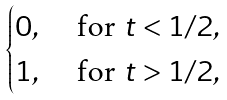<formula> <loc_0><loc_0><loc_500><loc_500>\begin{cases} 0 , \ & \text {for } t < 1 / 2 , \\ 1 , \ & \text {for } t > 1 / 2 , \end{cases}</formula> 